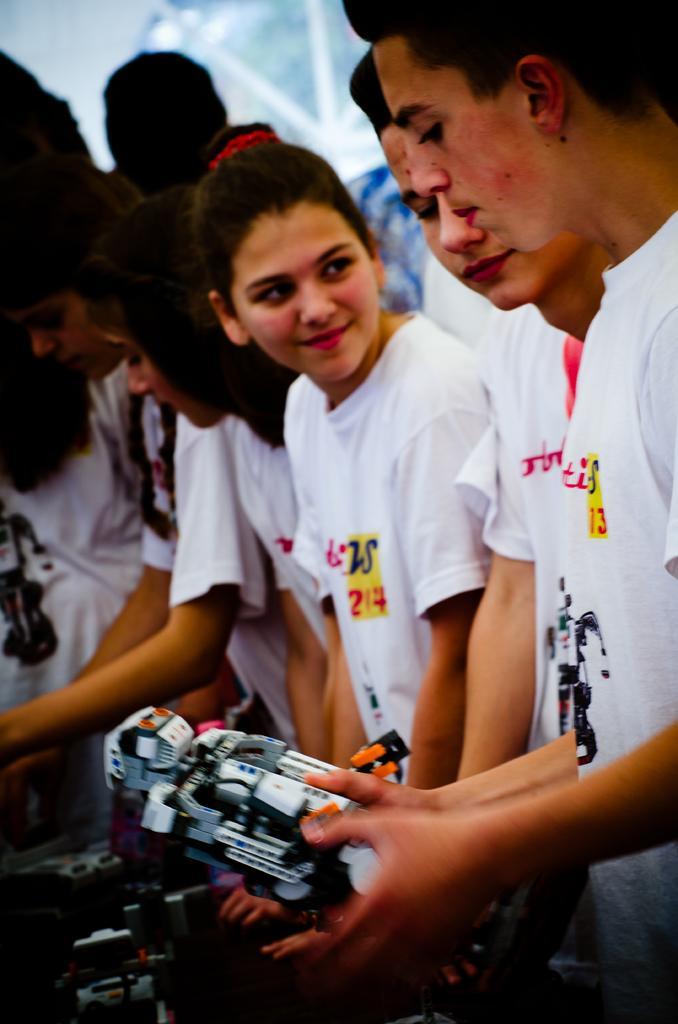How would you summarize this image in a sentence or two? In the picture we can see some boys and girls are sitting they are wearing a white T-shirts and one boy is holding some toy in the hand and in the background we can see a wall with a glass window. 